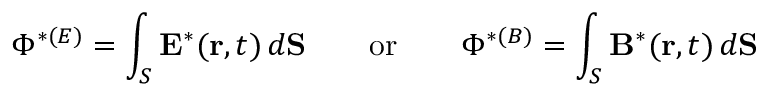<formula> <loc_0><loc_0><loc_500><loc_500>\Phi ^ { * ( E ) } = \int _ { S } { E } ^ { * } ( { r } , t ) \, d { S } \quad o r \quad \Phi ^ { * ( B ) } = \int _ { S } { B } ^ { * } ( { r } , t ) \, d { S }</formula> 